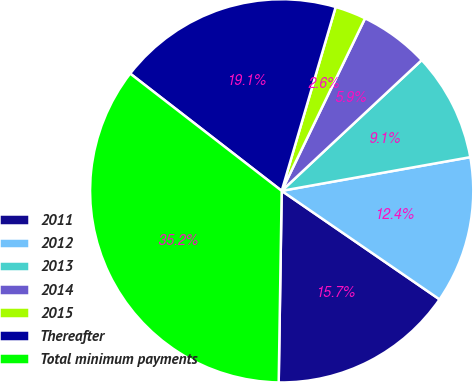Convert chart. <chart><loc_0><loc_0><loc_500><loc_500><pie_chart><fcel>2011<fcel>2012<fcel>2013<fcel>2014<fcel>2015<fcel>Thereafter<fcel>Total minimum payments<nl><fcel>15.66%<fcel>12.4%<fcel>9.14%<fcel>5.88%<fcel>2.62%<fcel>19.06%<fcel>35.23%<nl></chart> 